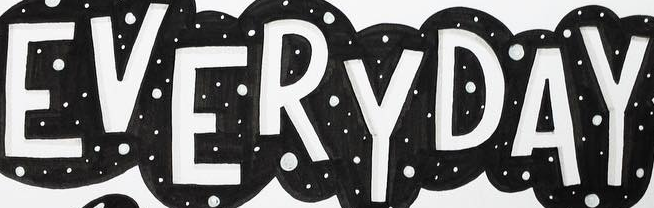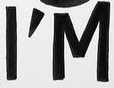Read the text content from these images in order, separated by a semicolon. EVERYDAY; I'M 